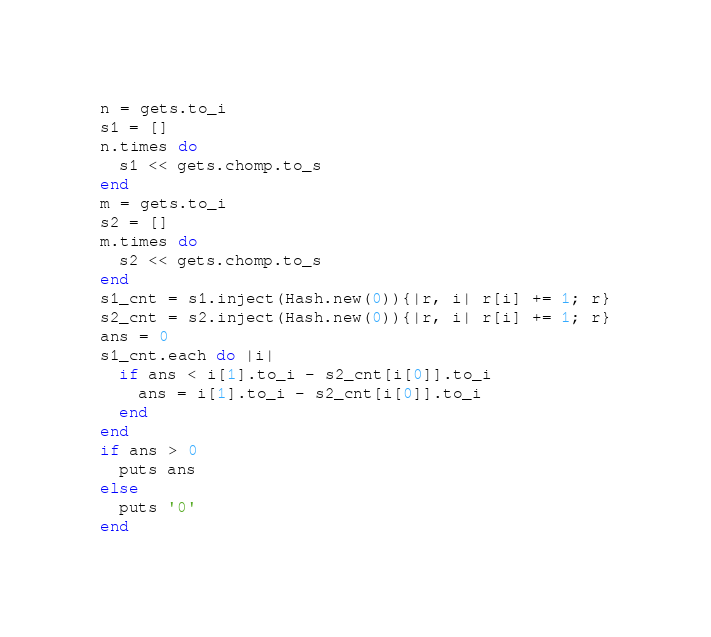Convert code to text. <code><loc_0><loc_0><loc_500><loc_500><_Ruby_>n = gets.to_i
s1 = []
n.times do
  s1 << gets.chomp.to_s
end
m = gets.to_i
s2 = []
m.times do
  s2 << gets.chomp.to_s
end
s1_cnt = s1.inject(Hash.new(0)){|r, i| r[i] += 1; r}
s2_cnt = s2.inject(Hash.new(0)){|r, i| r[i] += 1; r}
ans = 0
s1_cnt.each do |i|
  if ans < i[1].to_i - s2_cnt[i[0]].to_i
    ans = i[1].to_i - s2_cnt[i[0]].to_i
  end
end
if ans > 0
  puts ans
else
  puts '0'
end
</code> 